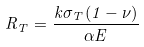Convert formula to latex. <formula><loc_0><loc_0><loc_500><loc_500>R _ { T } = \frac { k \sigma _ { T } ( 1 - \nu ) } { \alpha E }</formula> 